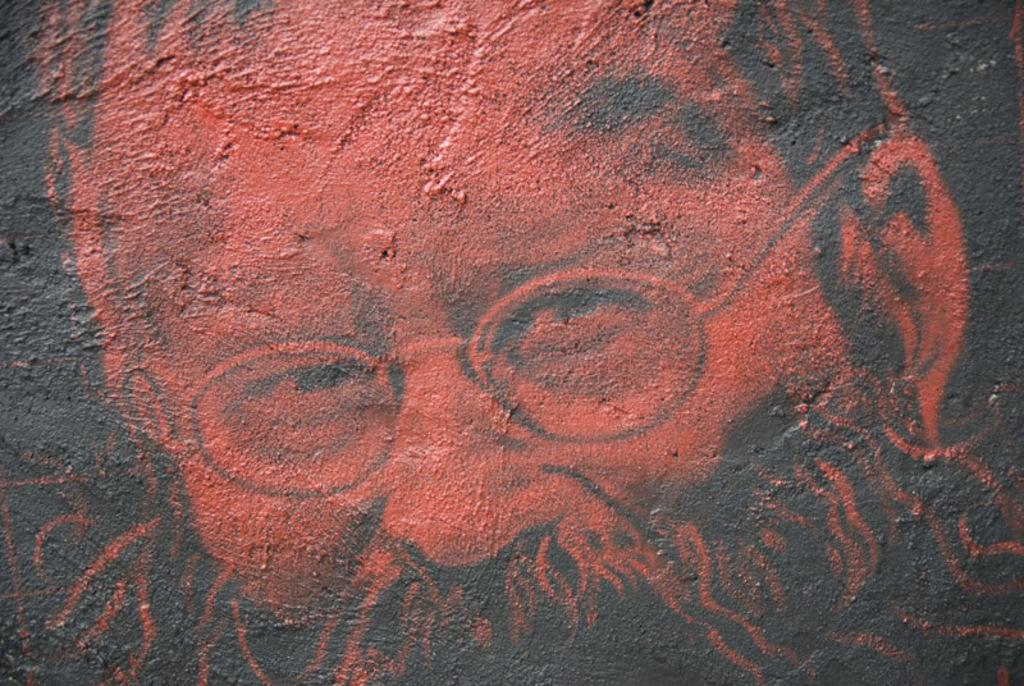What is the main subject of the image? There is an art piece in the image. What is depicted in the art piece? The art piece contains a person's face. What is the cause of the art piece's creation in the image? The image does not provide information about the cause of the art piece's creation. 